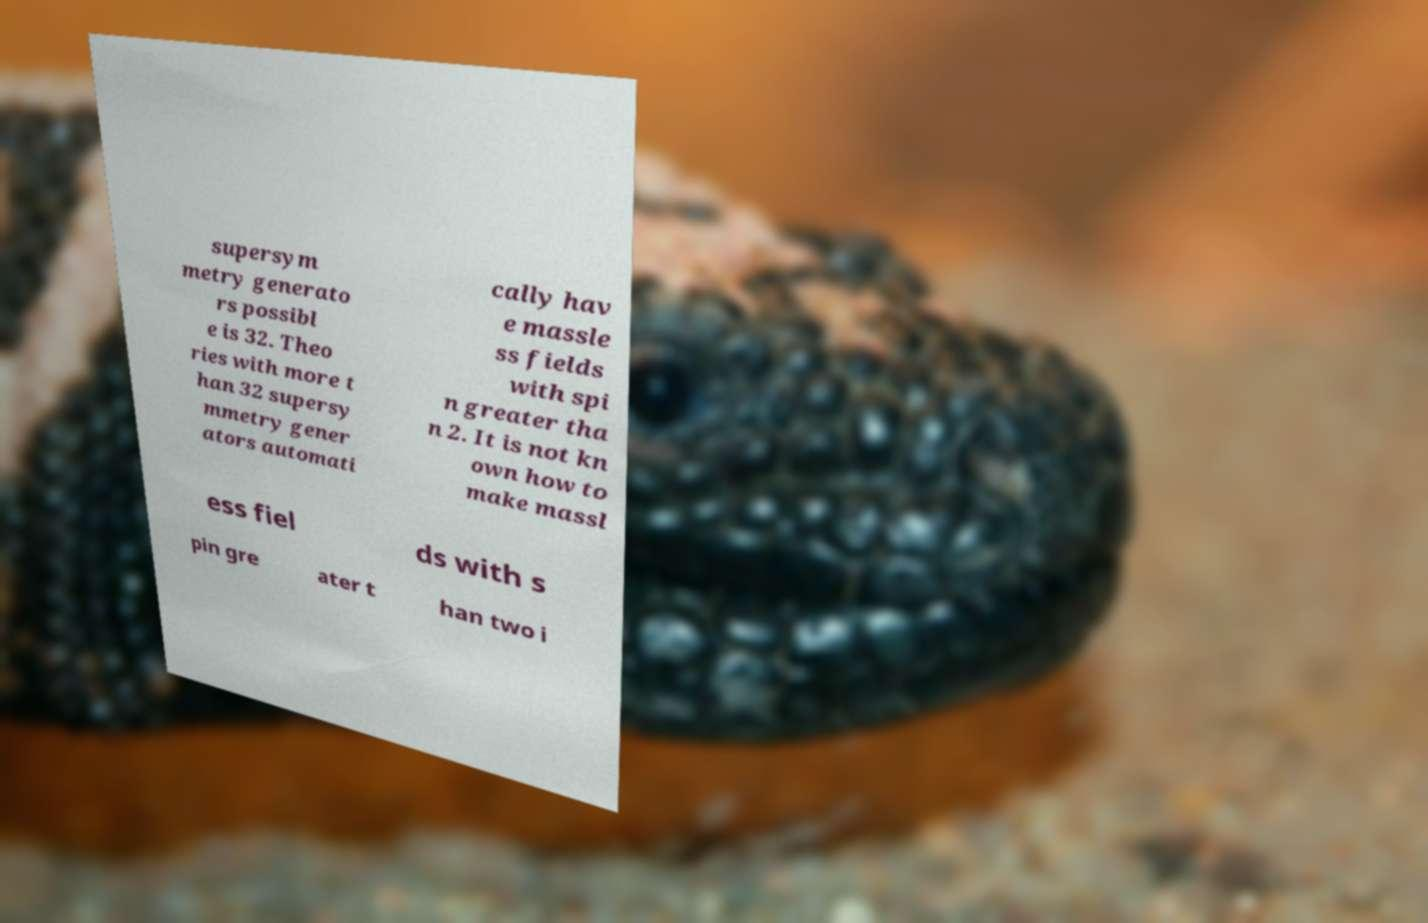Please identify and transcribe the text found in this image. supersym metry generato rs possibl e is 32. Theo ries with more t han 32 supersy mmetry gener ators automati cally hav e massle ss fields with spi n greater tha n 2. It is not kn own how to make massl ess fiel ds with s pin gre ater t han two i 